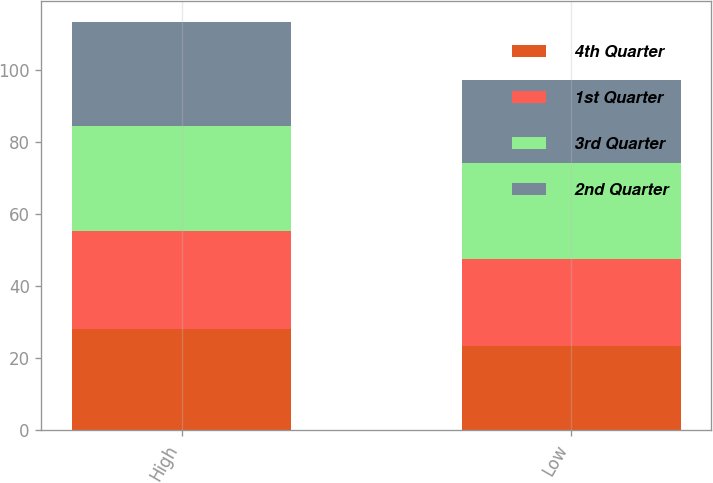Convert chart. <chart><loc_0><loc_0><loc_500><loc_500><stacked_bar_chart><ecel><fcel>High<fcel>Low<nl><fcel>4th Quarter<fcel>28.02<fcel>23.32<nl><fcel>1st Quarter<fcel>27.29<fcel>24.13<nl><fcel>3rd Quarter<fcel>29.09<fcel>26.9<nl><fcel>2nd Quarter<fcel>29.17<fcel>23.01<nl></chart> 